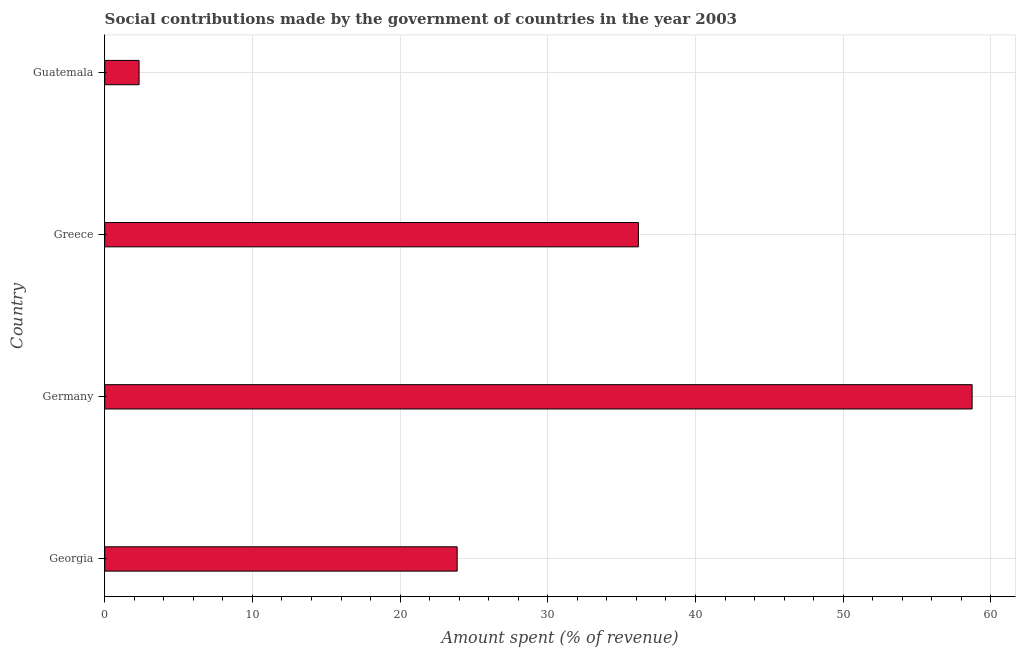Does the graph contain any zero values?
Offer a very short reply. No. What is the title of the graph?
Provide a succinct answer. Social contributions made by the government of countries in the year 2003. What is the label or title of the X-axis?
Keep it short and to the point. Amount spent (% of revenue). What is the label or title of the Y-axis?
Make the answer very short. Country. What is the amount spent in making social contributions in Guatemala?
Give a very brief answer. 2.33. Across all countries, what is the maximum amount spent in making social contributions?
Ensure brevity in your answer.  58.73. Across all countries, what is the minimum amount spent in making social contributions?
Make the answer very short. 2.33. In which country was the amount spent in making social contributions maximum?
Keep it short and to the point. Germany. In which country was the amount spent in making social contributions minimum?
Offer a terse response. Guatemala. What is the sum of the amount spent in making social contributions?
Offer a terse response. 121.04. What is the difference between the amount spent in making social contributions in Germany and Greece?
Your response must be concise. 22.6. What is the average amount spent in making social contributions per country?
Your answer should be very brief. 30.26. What is the median amount spent in making social contributions?
Ensure brevity in your answer.  30. What is the ratio of the amount spent in making social contributions in Germany to that in Greece?
Your answer should be very brief. 1.62. Is the amount spent in making social contributions in Greece less than that in Guatemala?
Your answer should be compact. No. Is the difference between the amount spent in making social contributions in Georgia and Greece greater than the difference between any two countries?
Make the answer very short. No. What is the difference between the highest and the second highest amount spent in making social contributions?
Your answer should be compact. 22.6. Is the sum of the amount spent in making social contributions in Germany and Greece greater than the maximum amount spent in making social contributions across all countries?
Give a very brief answer. Yes. What is the difference between the highest and the lowest amount spent in making social contributions?
Provide a succinct answer. 56.4. In how many countries, is the amount spent in making social contributions greater than the average amount spent in making social contributions taken over all countries?
Ensure brevity in your answer.  2. What is the difference between two consecutive major ticks on the X-axis?
Give a very brief answer. 10. What is the Amount spent (% of revenue) of Georgia?
Ensure brevity in your answer.  23.86. What is the Amount spent (% of revenue) in Germany?
Ensure brevity in your answer.  58.73. What is the Amount spent (% of revenue) of Greece?
Ensure brevity in your answer.  36.13. What is the Amount spent (% of revenue) in Guatemala?
Your answer should be very brief. 2.33. What is the difference between the Amount spent (% of revenue) in Georgia and Germany?
Keep it short and to the point. -34.86. What is the difference between the Amount spent (% of revenue) in Georgia and Greece?
Give a very brief answer. -12.27. What is the difference between the Amount spent (% of revenue) in Georgia and Guatemala?
Ensure brevity in your answer.  21.54. What is the difference between the Amount spent (% of revenue) in Germany and Greece?
Your answer should be compact. 22.6. What is the difference between the Amount spent (% of revenue) in Germany and Guatemala?
Offer a very short reply. 56.4. What is the difference between the Amount spent (% of revenue) in Greece and Guatemala?
Provide a short and direct response. 33.8. What is the ratio of the Amount spent (% of revenue) in Georgia to that in Germany?
Provide a succinct answer. 0.41. What is the ratio of the Amount spent (% of revenue) in Georgia to that in Greece?
Give a very brief answer. 0.66. What is the ratio of the Amount spent (% of revenue) in Georgia to that in Guatemala?
Offer a terse response. 10.26. What is the ratio of the Amount spent (% of revenue) in Germany to that in Greece?
Provide a succinct answer. 1.62. What is the ratio of the Amount spent (% of revenue) in Germany to that in Guatemala?
Your response must be concise. 25.25. What is the ratio of the Amount spent (% of revenue) in Greece to that in Guatemala?
Your answer should be very brief. 15.53. 